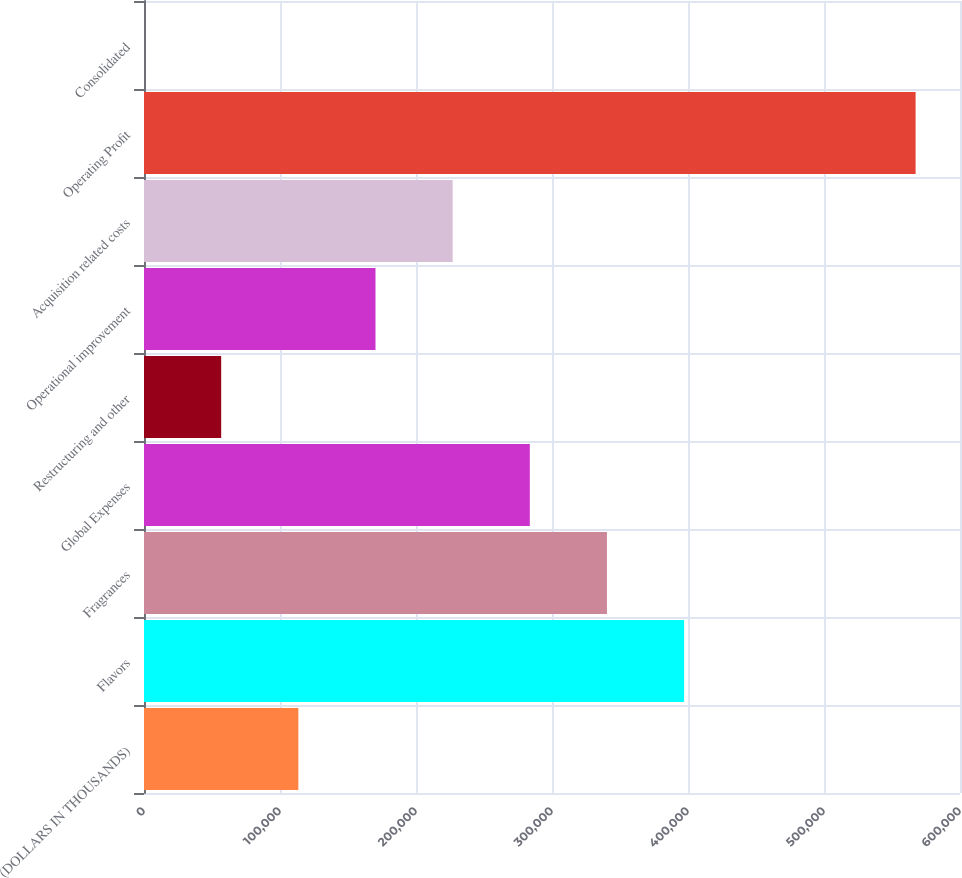Convert chart to OTSL. <chart><loc_0><loc_0><loc_500><loc_500><bar_chart><fcel>(DOLLARS IN THOUSANDS)<fcel>Flavors<fcel>Fragrances<fcel>Global Expenses<fcel>Restructuring and other<fcel>Operational improvement<fcel>Acquisition related costs<fcel>Operating Profit<fcel>Consolidated<nl><fcel>113486<fcel>397155<fcel>340421<fcel>283687<fcel>56752<fcel>170220<fcel>226953<fcel>567356<fcel>18.2<nl></chart> 